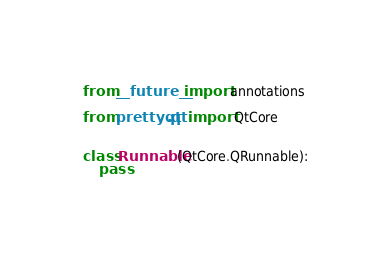Convert code to text. <code><loc_0><loc_0><loc_500><loc_500><_Python_>from __future__ import annotations

from prettyqt.qt import QtCore


class Runnable(QtCore.QRunnable):
    pass
</code> 